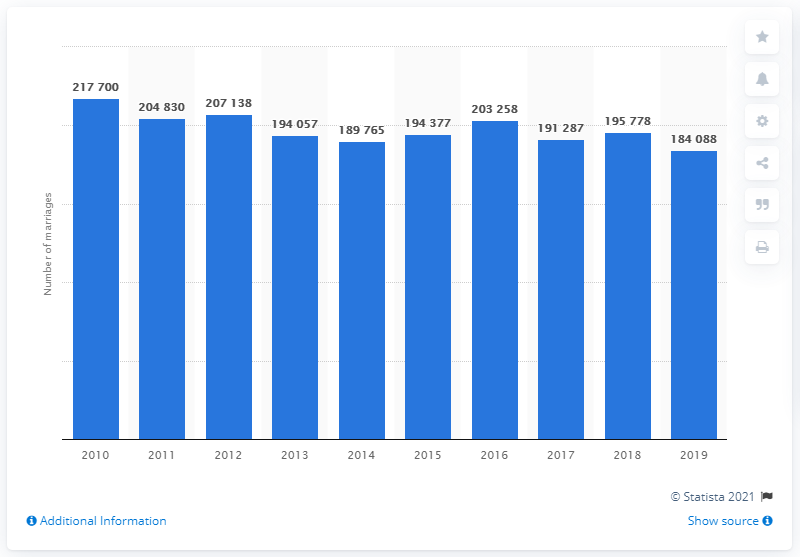Specify some key components in this picture. In 2010, a total of 217,700 marriages were registered in Italy. 